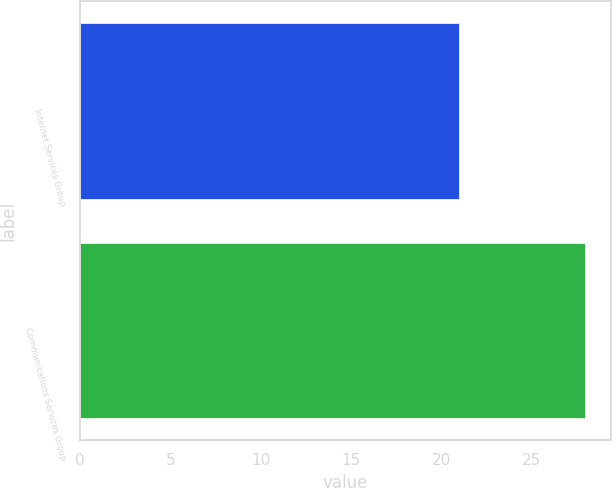<chart> <loc_0><loc_0><loc_500><loc_500><bar_chart><fcel>Internet Services Group<fcel>Communications Services Group<nl><fcel>21<fcel>28<nl></chart> 